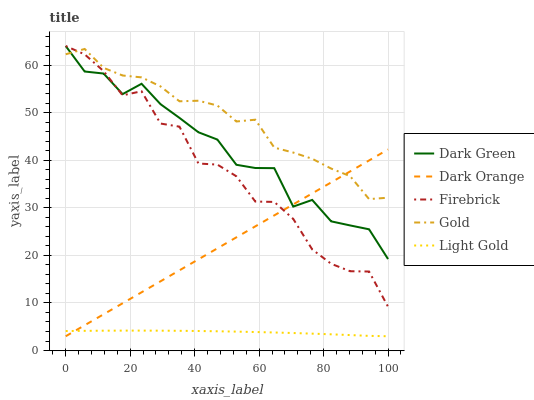Does Firebrick have the minimum area under the curve?
Answer yes or no. No. Does Firebrick have the maximum area under the curve?
Answer yes or no. No. Is Light Gold the smoothest?
Answer yes or no. No. Is Light Gold the roughest?
Answer yes or no. No. Does Firebrick have the lowest value?
Answer yes or no. No. Does Light Gold have the highest value?
Answer yes or no. No. Is Light Gold less than Gold?
Answer yes or no. Yes. Is Gold greater than Light Gold?
Answer yes or no. Yes. Does Light Gold intersect Gold?
Answer yes or no. No. 